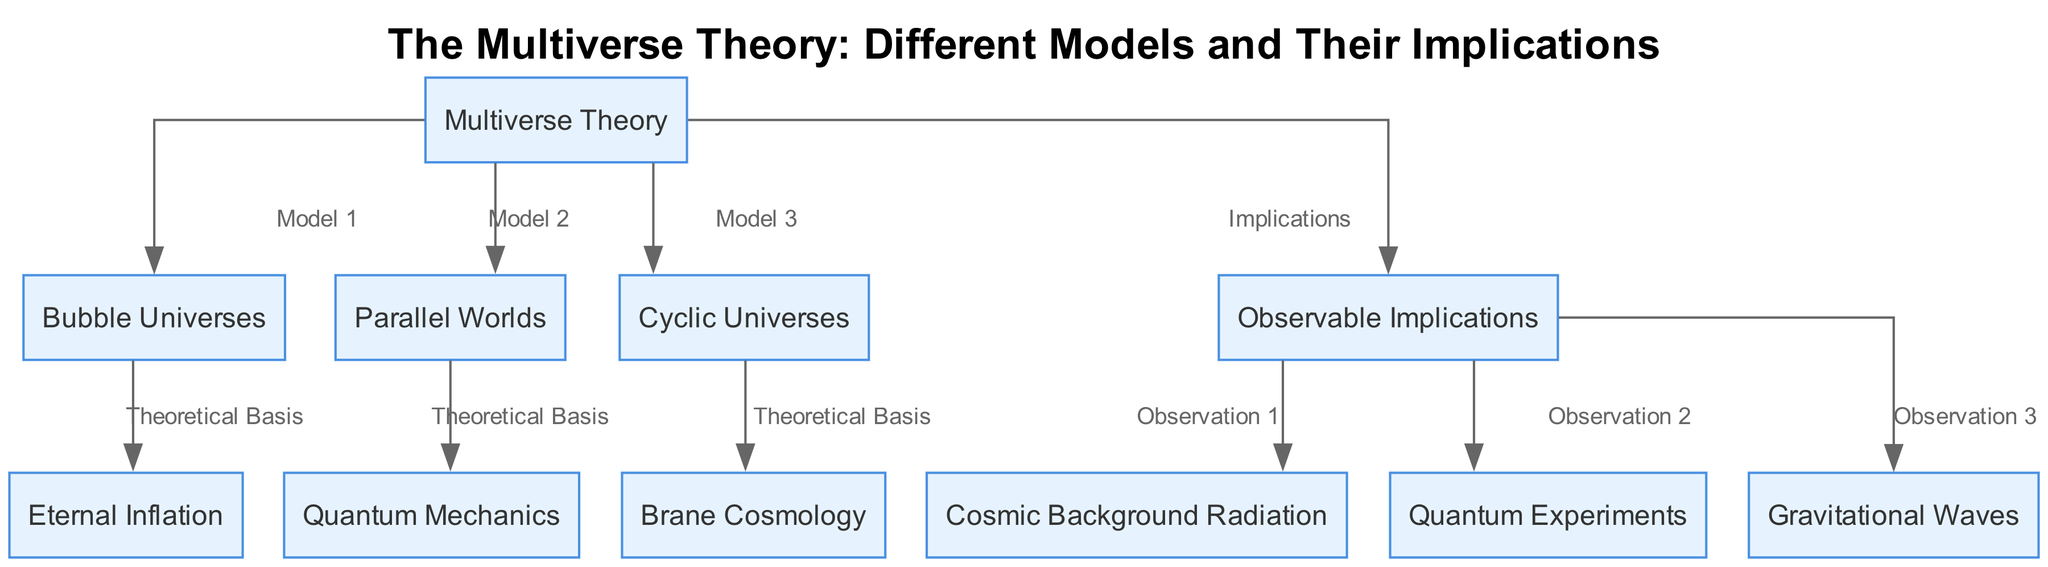What is the main title of the diagram? The main title of the diagram is prominently displayed at the top, and it states the overall topic being discussed. In this case, the title specifically indicates that it is about "The Multiverse Theory: Different Models and Their Implications."
Answer: The Multiverse Theory: Different Models and Their Implications How many nodes are there in the diagram? Counting each unique labeled node in the diagram, we find a total of 11 distinct nodes, as indicated by the list of nodes provided in the data.
Answer: 11 Which model is connected to "Quantum Mechanics"? To answer this, we look at the edges in the diagram. The edge illustrates that "Parallel Worlds" (node 3) is connected to "Quantum Mechanics" (node 6) as its theoretical basis.
Answer: Parallel Worlds What connects "Bubble Universes" to "Observable Implications"? The relationship can be established by examining the edge connections. There is no direct edge between "Bubble Universes" (node 2) and "Observable Implications" (node 8); instead, "Bubble Universes" connects to "Eternal Inflation" (node 5), which then contributes to "Observable Implications." Thus, the connection is indirect through "Eternal Inflation."
Answer: Eternal Inflation Which observational implication is related to "Gravitational Waves"? To find the observational implication, we look for the connection from "Observable Implications" (node 8) to "Gravitational Waves" (node 11). The diagram explicitly indicates that "Gravitational Waves" is one of the results or observations stemming from the implications of the multiverse theory.
Answer: Gravitational Waves What theoretical basis underpins both "Cyclic Universes" and "Brane Cosmology"? Analyzing the diagram's edges, we note that "Cyclic Universes" (node 4) is connected to "Brane Cosmology" (node 7) via the "Theoretical Basis" label. However, both are independent entities linked to the broader "Multiverse Theory." Each has its distinct theoretical basis, so the answer would emphasize their relationship to the overarching multiverse framework rather than a direct connection between them.
Answer: Theoretical Basis How many observable implications are represented in the diagram? Observing the structure of the diagram, we see that "Observable Implications" (node 8) has three direct connections to nodes representing observations: "Cosmic Background Radiation" (node 9), "Quantum Experiments" (node 10), and "Gravitational Waves" (node 11). This gives a total of three observable implications represented in the diagram.
Answer: 3 What is the relationship type between "Cyclic Universes" and "Brane Cosmology"? There is a directed edge connecting both nodes from "Cyclic Universes" to "Brane Cosmology" labeled as "Theoretical Basis." This indicates that both models share a theoretical foundation concerning multiverse theory, highlighting their interconnection in the context of modern physics.
Answer: Theoretical Basis What is the label for the connection from "Eternal Inflation"? The connection from "Eternal Inflation" (node 5) to "Bubble Universes" (node 2) is labeled "Theoretical Basis." This suggests that "Eternal Inflation" serves as the underpinning foundational concept for "Bubble Universes" in the multiverse framework.
Answer: Theoretical Basis 